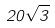Convert formula to latex. <formula><loc_0><loc_0><loc_500><loc_500>2 0 \sqrt { 3 }</formula> 